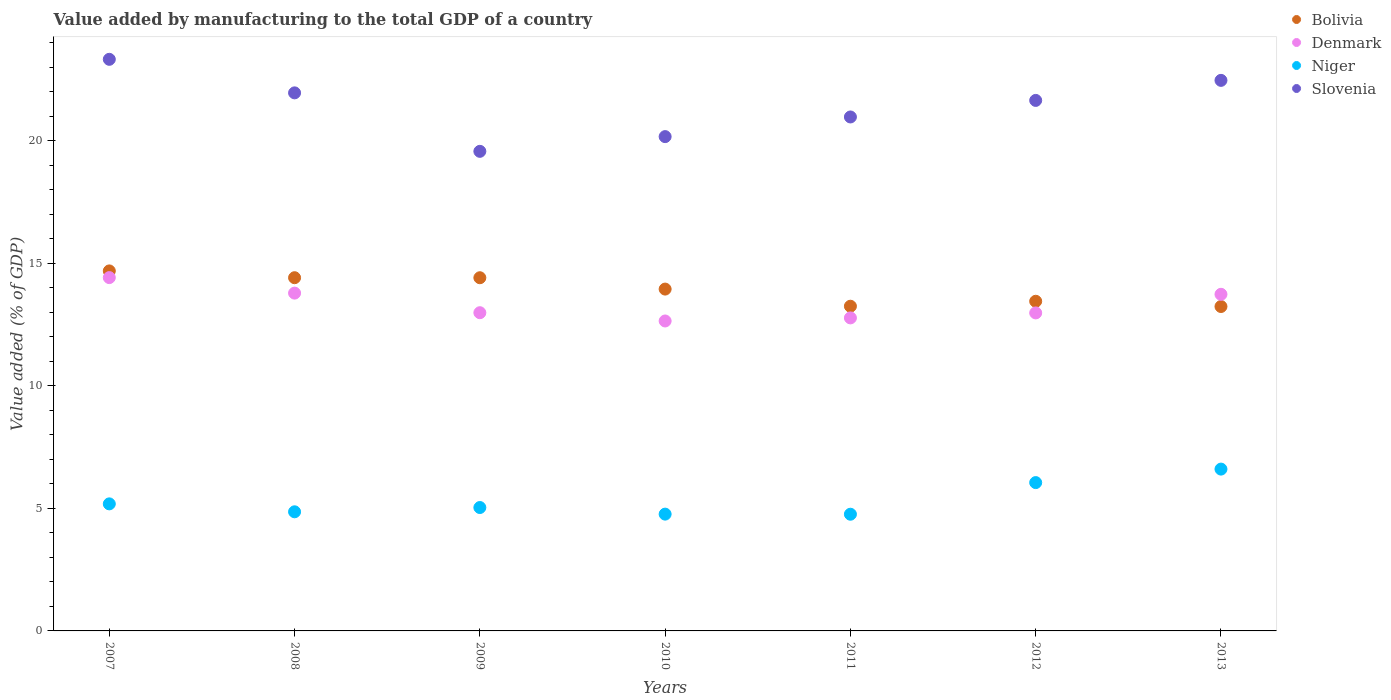How many different coloured dotlines are there?
Offer a very short reply. 4. What is the value added by manufacturing to the total GDP in Bolivia in 2010?
Make the answer very short. 13.94. Across all years, what is the maximum value added by manufacturing to the total GDP in Denmark?
Keep it short and to the point. 14.41. Across all years, what is the minimum value added by manufacturing to the total GDP in Denmark?
Ensure brevity in your answer.  12.64. In which year was the value added by manufacturing to the total GDP in Bolivia maximum?
Your response must be concise. 2007. In which year was the value added by manufacturing to the total GDP in Bolivia minimum?
Offer a terse response. 2013. What is the total value added by manufacturing to the total GDP in Niger in the graph?
Offer a terse response. 37.25. What is the difference between the value added by manufacturing to the total GDP in Bolivia in 2008 and that in 2013?
Offer a terse response. 1.17. What is the difference between the value added by manufacturing to the total GDP in Denmark in 2007 and the value added by manufacturing to the total GDP in Bolivia in 2012?
Provide a succinct answer. 0.97. What is the average value added by manufacturing to the total GDP in Niger per year?
Provide a short and direct response. 5.32. In the year 2010, what is the difference between the value added by manufacturing to the total GDP in Denmark and value added by manufacturing to the total GDP in Bolivia?
Keep it short and to the point. -1.3. What is the ratio of the value added by manufacturing to the total GDP in Bolivia in 2011 to that in 2013?
Your answer should be compact. 1. Is the value added by manufacturing to the total GDP in Niger in 2009 less than that in 2010?
Keep it short and to the point. No. What is the difference between the highest and the second highest value added by manufacturing to the total GDP in Denmark?
Provide a succinct answer. 0.63. What is the difference between the highest and the lowest value added by manufacturing to the total GDP in Denmark?
Your response must be concise. 1.77. Is the value added by manufacturing to the total GDP in Slovenia strictly less than the value added by manufacturing to the total GDP in Bolivia over the years?
Provide a succinct answer. No. How many dotlines are there?
Make the answer very short. 4. How many years are there in the graph?
Provide a succinct answer. 7. What is the difference between two consecutive major ticks on the Y-axis?
Give a very brief answer. 5. Does the graph contain grids?
Make the answer very short. No. What is the title of the graph?
Keep it short and to the point. Value added by manufacturing to the total GDP of a country. Does "Other small states" appear as one of the legend labels in the graph?
Offer a very short reply. No. What is the label or title of the X-axis?
Provide a short and direct response. Years. What is the label or title of the Y-axis?
Give a very brief answer. Value added (% of GDP). What is the Value added (% of GDP) of Bolivia in 2007?
Your response must be concise. 14.68. What is the Value added (% of GDP) of Denmark in 2007?
Ensure brevity in your answer.  14.41. What is the Value added (% of GDP) in Niger in 2007?
Provide a short and direct response. 5.18. What is the Value added (% of GDP) in Slovenia in 2007?
Provide a succinct answer. 23.31. What is the Value added (% of GDP) in Bolivia in 2008?
Give a very brief answer. 14.41. What is the Value added (% of GDP) in Denmark in 2008?
Keep it short and to the point. 13.78. What is the Value added (% of GDP) in Niger in 2008?
Your answer should be compact. 4.86. What is the Value added (% of GDP) of Slovenia in 2008?
Ensure brevity in your answer.  21.95. What is the Value added (% of GDP) of Bolivia in 2009?
Make the answer very short. 14.41. What is the Value added (% of GDP) of Denmark in 2009?
Your response must be concise. 12.98. What is the Value added (% of GDP) of Niger in 2009?
Provide a succinct answer. 5.03. What is the Value added (% of GDP) in Slovenia in 2009?
Offer a terse response. 19.56. What is the Value added (% of GDP) of Bolivia in 2010?
Your answer should be very brief. 13.94. What is the Value added (% of GDP) of Denmark in 2010?
Make the answer very short. 12.64. What is the Value added (% of GDP) in Niger in 2010?
Keep it short and to the point. 4.76. What is the Value added (% of GDP) in Slovenia in 2010?
Offer a terse response. 20.16. What is the Value added (% of GDP) in Bolivia in 2011?
Provide a short and direct response. 13.24. What is the Value added (% of GDP) of Denmark in 2011?
Provide a short and direct response. 12.77. What is the Value added (% of GDP) in Niger in 2011?
Offer a terse response. 4.76. What is the Value added (% of GDP) of Slovenia in 2011?
Give a very brief answer. 20.96. What is the Value added (% of GDP) of Bolivia in 2012?
Offer a terse response. 13.45. What is the Value added (% of GDP) of Denmark in 2012?
Keep it short and to the point. 12.97. What is the Value added (% of GDP) in Niger in 2012?
Your response must be concise. 6.05. What is the Value added (% of GDP) of Slovenia in 2012?
Keep it short and to the point. 21.64. What is the Value added (% of GDP) in Bolivia in 2013?
Give a very brief answer. 13.23. What is the Value added (% of GDP) of Denmark in 2013?
Ensure brevity in your answer.  13.73. What is the Value added (% of GDP) in Niger in 2013?
Give a very brief answer. 6.6. What is the Value added (% of GDP) in Slovenia in 2013?
Your answer should be compact. 22.45. Across all years, what is the maximum Value added (% of GDP) in Bolivia?
Ensure brevity in your answer.  14.68. Across all years, what is the maximum Value added (% of GDP) of Denmark?
Your response must be concise. 14.41. Across all years, what is the maximum Value added (% of GDP) of Niger?
Your answer should be very brief. 6.6. Across all years, what is the maximum Value added (% of GDP) of Slovenia?
Offer a terse response. 23.31. Across all years, what is the minimum Value added (% of GDP) of Bolivia?
Offer a terse response. 13.23. Across all years, what is the minimum Value added (% of GDP) of Denmark?
Offer a very short reply. 12.64. Across all years, what is the minimum Value added (% of GDP) in Niger?
Provide a succinct answer. 4.76. Across all years, what is the minimum Value added (% of GDP) in Slovenia?
Provide a short and direct response. 19.56. What is the total Value added (% of GDP) of Bolivia in the graph?
Keep it short and to the point. 97.36. What is the total Value added (% of GDP) in Denmark in the graph?
Keep it short and to the point. 93.27. What is the total Value added (% of GDP) in Niger in the graph?
Provide a short and direct response. 37.25. What is the total Value added (% of GDP) of Slovenia in the graph?
Keep it short and to the point. 150.03. What is the difference between the Value added (% of GDP) of Bolivia in 2007 and that in 2008?
Provide a succinct answer. 0.28. What is the difference between the Value added (% of GDP) of Denmark in 2007 and that in 2008?
Keep it short and to the point. 0.63. What is the difference between the Value added (% of GDP) of Niger in 2007 and that in 2008?
Give a very brief answer. 0.32. What is the difference between the Value added (% of GDP) of Slovenia in 2007 and that in 2008?
Offer a terse response. 1.37. What is the difference between the Value added (% of GDP) in Bolivia in 2007 and that in 2009?
Ensure brevity in your answer.  0.28. What is the difference between the Value added (% of GDP) in Denmark in 2007 and that in 2009?
Provide a short and direct response. 1.43. What is the difference between the Value added (% of GDP) in Niger in 2007 and that in 2009?
Provide a short and direct response. 0.15. What is the difference between the Value added (% of GDP) of Slovenia in 2007 and that in 2009?
Provide a short and direct response. 3.75. What is the difference between the Value added (% of GDP) in Bolivia in 2007 and that in 2010?
Ensure brevity in your answer.  0.74. What is the difference between the Value added (% of GDP) in Denmark in 2007 and that in 2010?
Provide a short and direct response. 1.77. What is the difference between the Value added (% of GDP) of Niger in 2007 and that in 2010?
Offer a terse response. 0.42. What is the difference between the Value added (% of GDP) of Slovenia in 2007 and that in 2010?
Provide a succinct answer. 3.15. What is the difference between the Value added (% of GDP) in Bolivia in 2007 and that in 2011?
Offer a very short reply. 1.44. What is the difference between the Value added (% of GDP) of Denmark in 2007 and that in 2011?
Give a very brief answer. 1.64. What is the difference between the Value added (% of GDP) of Niger in 2007 and that in 2011?
Make the answer very short. 0.42. What is the difference between the Value added (% of GDP) of Slovenia in 2007 and that in 2011?
Give a very brief answer. 2.35. What is the difference between the Value added (% of GDP) of Bolivia in 2007 and that in 2012?
Provide a short and direct response. 1.24. What is the difference between the Value added (% of GDP) in Denmark in 2007 and that in 2012?
Your response must be concise. 1.44. What is the difference between the Value added (% of GDP) of Niger in 2007 and that in 2012?
Your response must be concise. -0.87. What is the difference between the Value added (% of GDP) of Slovenia in 2007 and that in 2012?
Make the answer very short. 1.68. What is the difference between the Value added (% of GDP) of Bolivia in 2007 and that in 2013?
Your answer should be compact. 1.45. What is the difference between the Value added (% of GDP) of Denmark in 2007 and that in 2013?
Provide a short and direct response. 0.68. What is the difference between the Value added (% of GDP) in Niger in 2007 and that in 2013?
Provide a succinct answer. -1.42. What is the difference between the Value added (% of GDP) in Slovenia in 2007 and that in 2013?
Provide a succinct answer. 0.86. What is the difference between the Value added (% of GDP) in Bolivia in 2008 and that in 2009?
Offer a very short reply. 0. What is the difference between the Value added (% of GDP) in Denmark in 2008 and that in 2009?
Make the answer very short. 0.8. What is the difference between the Value added (% of GDP) in Niger in 2008 and that in 2009?
Your response must be concise. -0.17. What is the difference between the Value added (% of GDP) of Slovenia in 2008 and that in 2009?
Ensure brevity in your answer.  2.39. What is the difference between the Value added (% of GDP) of Bolivia in 2008 and that in 2010?
Keep it short and to the point. 0.46. What is the difference between the Value added (% of GDP) in Denmark in 2008 and that in 2010?
Give a very brief answer. 1.14. What is the difference between the Value added (% of GDP) in Niger in 2008 and that in 2010?
Provide a succinct answer. 0.09. What is the difference between the Value added (% of GDP) of Slovenia in 2008 and that in 2010?
Ensure brevity in your answer.  1.78. What is the difference between the Value added (% of GDP) in Bolivia in 2008 and that in 2011?
Your answer should be compact. 1.16. What is the difference between the Value added (% of GDP) of Denmark in 2008 and that in 2011?
Offer a terse response. 1.01. What is the difference between the Value added (% of GDP) of Niger in 2008 and that in 2011?
Offer a very short reply. 0.1. What is the difference between the Value added (% of GDP) of Slovenia in 2008 and that in 2011?
Your answer should be compact. 0.98. What is the difference between the Value added (% of GDP) in Bolivia in 2008 and that in 2012?
Provide a short and direct response. 0.96. What is the difference between the Value added (% of GDP) of Denmark in 2008 and that in 2012?
Provide a short and direct response. 0.81. What is the difference between the Value added (% of GDP) in Niger in 2008 and that in 2012?
Provide a short and direct response. -1.19. What is the difference between the Value added (% of GDP) in Slovenia in 2008 and that in 2012?
Provide a short and direct response. 0.31. What is the difference between the Value added (% of GDP) in Bolivia in 2008 and that in 2013?
Give a very brief answer. 1.17. What is the difference between the Value added (% of GDP) of Denmark in 2008 and that in 2013?
Provide a succinct answer. 0.05. What is the difference between the Value added (% of GDP) in Niger in 2008 and that in 2013?
Offer a terse response. -1.74. What is the difference between the Value added (% of GDP) of Slovenia in 2008 and that in 2013?
Ensure brevity in your answer.  -0.51. What is the difference between the Value added (% of GDP) in Bolivia in 2009 and that in 2010?
Make the answer very short. 0.46. What is the difference between the Value added (% of GDP) of Denmark in 2009 and that in 2010?
Your answer should be very brief. 0.34. What is the difference between the Value added (% of GDP) in Niger in 2009 and that in 2010?
Give a very brief answer. 0.27. What is the difference between the Value added (% of GDP) in Slovenia in 2009 and that in 2010?
Your answer should be compact. -0.6. What is the difference between the Value added (% of GDP) in Bolivia in 2009 and that in 2011?
Your response must be concise. 1.16. What is the difference between the Value added (% of GDP) in Denmark in 2009 and that in 2011?
Ensure brevity in your answer.  0.21. What is the difference between the Value added (% of GDP) of Niger in 2009 and that in 2011?
Your answer should be very brief. 0.27. What is the difference between the Value added (% of GDP) in Slovenia in 2009 and that in 2011?
Give a very brief answer. -1.4. What is the difference between the Value added (% of GDP) in Bolivia in 2009 and that in 2012?
Make the answer very short. 0.96. What is the difference between the Value added (% of GDP) of Denmark in 2009 and that in 2012?
Your answer should be very brief. 0.01. What is the difference between the Value added (% of GDP) of Niger in 2009 and that in 2012?
Ensure brevity in your answer.  -1.02. What is the difference between the Value added (% of GDP) in Slovenia in 2009 and that in 2012?
Your answer should be compact. -2.08. What is the difference between the Value added (% of GDP) in Bolivia in 2009 and that in 2013?
Provide a succinct answer. 1.17. What is the difference between the Value added (% of GDP) of Denmark in 2009 and that in 2013?
Give a very brief answer. -0.75. What is the difference between the Value added (% of GDP) of Niger in 2009 and that in 2013?
Keep it short and to the point. -1.57. What is the difference between the Value added (% of GDP) in Slovenia in 2009 and that in 2013?
Keep it short and to the point. -2.89. What is the difference between the Value added (% of GDP) in Bolivia in 2010 and that in 2011?
Your response must be concise. 0.7. What is the difference between the Value added (% of GDP) of Denmark in 2010 and that in 2011?
Your answer should be compact. -0.13. What is the difference between the Value added (% of GDP) in Niger in 2010 and that in 2011?
Your answer should be compact. 0. What is the difference between the Value added (% of GDP) in Slovenia in 2010 and that in 2011?
Provide a short and direct response. -0.8. What is the difference between the Value added (% of GDP) in Bolivia in 2010 and that in 2012?
Make the answer very short. 0.5. What is the difference between the Value added (% of GDP) in Denmark in 2010 and that in 2012?
Your answer should be very brief. -0.33. What is the difference between the Value added (% of GDP) in Niger in 2010 and that in 2012?
Ensure brevity in your answer.  -1.29. What is the difference between the Value added (% of GDP) of Slovenia in 2010 and that in 2012?
Your answer should be very brief. -1.48. What is the difference between the Value added (% of GDP) of Bolivia in 2010 and that in 2013?
Offer a terse response. 0.71. What is the difference between the Value added (% of GDP) of Denmark in 2010 and that in 2013?
Your answer should be compact. -1.09. What is the difference between the Value added (% of GDP) in Niger in 2010 and that in 2013?
Provide a short and direct response. -1.84. What is the difference between the Value added (% of GDP) of Slovenia in 2010 and that in 2013?
Keep it short and to the point. -2.29. What is the difference between the Value added (% of GDP) of Bolivia in 2011 and that in 2012?
Make the answer very short. -0.2. What is the difference between the Value added (% of GDP) of Denmark in 2011 and that in 2012?
Offer a very short reply. -0.2. What is the difference between the Value added (% of GDP) in Niger in 2011 and that in 2012?
Ensure brevity in your answer.  -1.29. What is the difference between the Value added (% of GDP) in Slovenia in 2011 and that in 2012?
Keep it short and to the point. -0.68. What is the difference between the Value added (% of GDP) in Bolivia in 2011 and that in 2013?
Provide a short and direct response. 0.01. What is the difference between the Value added (% of GDP) of Denmark in 2011 and that in 2013?
Give a very brief answer. -0.96. What is the difference between the Value added (% of GDP) of Niger in 2011 and that in 2013?
Your response must be concise. -1.84. What is the difference between the Value added (% of GDP) of Slovenia in 2011 and that in 2013?
Your answer should be compact. -1.49. What is the difference between the Value added (% of GDP) in Bolivia in 2012 and that in 2013?
Provide a succinct answer. 0.21. What is the difference between the Value added (% of GDP) of Denmark in 2012 and that in 2013?
Give a very brief answer. -0.76. What is the difference between the Value added (% of GDP) of Niger in 2012 and that in 2013?
Make the answer very short. -0.55. What is the difference between the Value added (% of GDP) in Slovenia in 2012 and that in 2013?
Offer a terse response. -0.82. What is the difference between the Value added (% of GDP) in Bolivia in 2007 and the Value added (% of GDP) in Denmark in 2008?
Give a very brief answer. 0.91. What is the difference between the Value added (% of GDP) in Bolivia in 2007 and the Value added (% of GDP) in Niger in 2008?
Offer a terse response. 9.82. What is the difference between the Value added (% of GDP) of Bolivia in 2007 and the Value added (% of GDP) of Slovenia in 2008?
Your answer should be very brief. -7.26. What is the difference between the Value added (% of GDP) of Denmark in 2007 and the Value added (% of GDP) of Niger in 2008?
Offer a terse response. 9.55. What is the difference between the Value added (% of GDP) of Denmark in 2007 and the Value added (% of GDP) of Slovenia in 2008?
Provide a succinct answer. -7.53. What is the difference between the Value added (% of GDP) in Niger in 2007 and the Value added (% of GDP) in Slovenia in 2008?
Provide a short and direct response. -16.76. What is the difference between the Value added (% of GDP) of Bolivia in 2007 and the Value added (% of GDP) of Denmark in 2009?
Your response must be concise. 1.7. What is the difference between the Value added (% of GDP) of Bolivia in 2007 and the Value added (% of GDP) of Niger in 2009?
Offer a very short reply. 9.65. What is the difference between the Value added (% of GDP) in Bolivia in 2007 and the Value added (% of GDP) in Slovenia in 2009?
Provide a succinct answer. -4.88. What is the difference between the Value added (% of GDP) of Denmark in 2007 and the Value added (% of GDP) of Niger in 2009?
Offer a very short reply. 9.38. What is the difference between the Value added (% of GDP) in Denmark in 2007 and the Value added (% of GDP) in Slovenia in 2009?
Provide a succinct answer. -5.15. What is the difference between the Value added (% of GDP) in Niger in 2007 and the Value added (% of GDP) in Slovenia in 2009?
Your answer should be very brief. -14.38. What is the difference between the Value added (% of GDP) of Bolivia in 2007 and the Value added (% of GDP) of Denmark in 2010?
Offer a terse response. 2.04. What is the difference between the Value added (% of GDP) in Bolivia in 2007 and the Value added (% of GDP) in Niger in 2010?
Your answer should be compact. 9.92. What is the difference between the Value added (% of GDP) of Bolivia in 2007 and the Value added (% of GDP) of Slovenia in 2010?
Provide a succinct answer. -5.48. What is the difference between the Value added (% of GDP) in Denmark in 2007 and the Value added (% of GDP) in Niger in 2010?
Your answer should be compact. 9.65. What is the difference between the Value added (% of GDP) of Denmark in 2007 and the Value added (% of GDP) of Slovenia in 2010?
Make the answer very short. -5.75. What is the difference between the Value added (% of GDP) in Niger in 2007 and the Value added (% of GDP) in Slovenia in 2010?
Your answer should be compact. -14.98. What is the difference between the Value added (% of GDP) in Bolivia in 2007 and the Value added (% of GDP) in Denmark in 2011?
Ensure brevity in your answer.  1.92. What is the difference between the Value added (% of GDP) of Bolivia in 2007 and the Value added (% of GDP) of Niger in 2011?
Provide a short and direct response. 9.92. What is the difference between the Value added (% of GDP) in Bolivia in 2007 and the Value added (% of GDP) in Slovenia in 2011?
Your response must be concise. -6.28. What is the difference between the Value added (% of GDP) in Denmark in 2007 and the Value added (% of GDP) in Niger in 2011?
Keep it short and to the point. 9.65. What is the difference between the Value added (% of GDP) in Denmark in 2007 and the Value added (% of GDP) in Slovenia in 2011?
Give a very brief answer. -6.55. What is the difference between the Value added (% of GDP) in Niger in 2007 and the Value added (% of GDP) in Slovenia in 2011?
Give a very brief answer. -15.78. What is the difference between the Value added (% of GDP) in Bolivia in 2007 and the Value added (% of GDP) in Denmark in 2012?
Provide a short and direct response. 1.71. What is the difference between the Value added (% of GDP) of Bolivia in 2007 and the Value added (% of GDP) of Niger in 2012?
Your answer should be very brief. 8.63. What is the difference between the Value added (% of GDP) of Bolivia in 2007 and the Value added (% of GDP) of Slovenia in 2012?
Ensure brevity in your answer.  -6.95. What is the difference between the Value added (% of GDP) in Denmark in 2007 and the Value added (% of GDP) in Niger in 2012?
Make the answer very short. 8.36. What is the difference between the Value added (% of GDP) in Denmark in 2007 and the Value added (% of GDP) in Slovenia in 2012?
Keep it short and to the point. -7.23. What is the difference between the Value added (% of GDP) of Niger in 2007 and the Value added (% of GDP) of Slovenia in 2012?
Ensure brevity in your answer.  -16.46. What is the difference between the Value added (% of GDP) in Bolivia in 2007 and the Value added (% of GDP) in Denmark in 2013?
Your response must be concise. 0.95. What is the difference between the Value added (% of GDP) of Bolivia in 2007 and the Value added (% of GDP) of Niger in 2013?
Your response must be concise. 8.08. What is the difference between the Value added (% of GDP) in Bolivia in 2007 and the Value added (% of GDP) in Slovenia in 2013?
Your answer should be compact. -7.77. What is the difference between the Value added (% of GDP) in Denmark in 2007 and the Value added (% of GDP) in Niger in 2013?
Your answer should be very brief. 7.81. What is the difference between the Value added (% of GDP) in Denmark in 2007 and the Value added (% of GDP) in Slovenia in 2013?
Your response must be concise. -8.04. What is the difference between the Value added (% of GDP) in Niger in 2007 and the Value added (% of GDP) in Slovenia in 2013?
Your response must be concise. -17.27. What is the difference between the Value added (% of GDP) of Bolivia in 2008 and the Value added (% of GDP) of Denmark in 2009?
Offer a terse response. 1.43. What is the difference between the Value added (% of GDP) of Bolivia in 2008 and the Value added (% of GDP) of Niger in 2009?
Offer a terse response. 9.37. What is the difference between the Value added (% of GDP) of Bolivia in 2008 and the Value added (% of GDP) of Slovenia in 2009?
Your response must be concise. -5.15. What is the difference between the Value added (% of GDP) in Denmark in 2008 and the Value added (% of GDP) in Niger in 2009?
Your answer should be compact. 8.75. What is the difference between the Value added (% of GDP) in Denmark in 2008 and the Value added (% of GDP) in Slovenia in 2009?
Offer a very short reply. -5.78. What is the difference between the Value added (% of GDP) in Niger in 2008 and the Value added (% of GDP) in Slovenia in 2009?
Give a very brief answer. -14.7. What is the difference between the Value added (% of GDP) in Bolivia in 2008 and the Value added (% of GDP) in Denmark in 2010?
Provide a succinct answer. 1.76. What is the difference between the Value added (% of GDP) in Bolivia in 2008 and the Value added (% of GDP) in Niger in 2010?
Keep it short and to the point. 9.64. What is the difference between the Value added (% of GDP) of Bolivia in 2008 and the Value added (% of GDP) of Slovenia in 2010?
Give a very brief answer. -5.75. What is the difference between the Value added (% of GDP) of Denmark in 2008 and the Value added (% of GDP) of Niger in 2010?
Your answer should be compact. 9.01. What is the difference between the Value added (% of GDP) of Denmark in 2008 and the Value added (% of GDP) of Slovenia in 2010?
Your answer should be compact. -6.38. What is the difference between the Value added (% of GDP) in Niger in 2008 and the Value added (% of GDP) in Slovenia in 2010?
Offer a terse response. -15.3. What is the difference between the Value added (% of GDP) of Bolivia in 2008 and the Value added (% of GDP) of Denmark in 2011?
Offer a terse response. 1.64. What is the difference between the Value added (% of GDP) of Bolivia in 2008 and the Value added (% of GDP) of Niger in 2011?
Offer a terse response. 9.65. What is the difference between the Value added (% of GDP) of Bolivia in 2008 and the Value added (% of GDP) of Slovenia in 2011?
Keep it short and to the point. -6.56. What is the difference between the Value added (% of GDP) of Denmark in 2008 and the Value added (% of GDP) of Niger in 2011?
Provide a succinct answer. 9.02. What is the difference between the Value added (% of GDP) of Denmark in 2008 and the Value added (% of GDP) of Slovenia in 2011?
Offer a terse response. -7.18. What is the difference between the Value added (% of GDP) of Niger in 2008 and the Value added (% of GDP) of Slovenia in 2011?
Your response must be concise. -16.1. What is the difference between the Value added (% of GDP) in Bolivia in 2008 and the Value added (% of GDP) in Denmark in 2012?
Offer a terse response. 1.44. What is the difference between the Value added (% of GDP) in Bolivia in 2008 and the Value added (% of GDP) in Niger in 2012?
Your answer should be compact. 8.36. What is the difference between the Value added (% of GDP) in Bolivia in 2008 and the Value added (% of GDP) in Slovenia in 2012?
Your answer should be very brief. -7.23. What is the difference between the Value added (% of GDP) in Denmark in 2008 and the Value added (% of GDP) in Niger in 2012?
Provide a short and direct response. 7.73. What is the difference between the Value added (% of GDP) of Denmark in 2008 and the Value added (% of GDP) of Slovenia in 2012?
Your answer should be very brief. -7.86. What is the difference between the Value added (% of GDP) of Niger in 2008 and the Value added (% of GDP) of Slovenia in 2012?
Give a very brief answer. -16.78. What is the difference between the Value added (% of GDP) of Bolivia in 2008 and the Value added (% of GDP) of Denmark in 2013?
Give a very brief answer. 0.68. What is the difference between the Value added (% of GDP) in Bolivia in 2008 and the Value added (% of GDP) in Niger in 2013?
Provide a succinct answer. 7.81. What is the difference between the Value added (% of GDP) in Bolivia in 2008 and the Value added (% of GDP) in Slovenia in 2013?
Provide a succinct answer. -8.05. What is the difference between the Value added (% of GDP) in Denmark in 2008 and the Value added (% of GDP) in Niger in 2013?
Provide a succinct answer. 7.18. What is the difference between the Value added (% of GDP) in Denmark in 2008 and the Value added (% of GDP) in Slovenia in 2013?
Provide a short and direct response. -8.68. What is the difference between the Value added (% of GDP) in Niger in 2008 and the Value added (% of GDP) in Slovenia in 2013?
Offer a terse response. -17.6. What is the difference between the Value added (% of GDP) of Bolivia in 2009 and the Value added (% of GDP) of Denmark in 2010?
Offer a terse response. 1.76. What is the difference between the Value added (% of GDP) in Bolivia in 2009 and the Value added (% of GDP) in Niger in 2010?
Your answer should be compact. 9.64. What is the difference between the Value added (% of GDP) of Bolivia in 2009 and the Value added (% of GDP) of Slovenia in 2010?
Give a very brief answer. -5.76. What is the difference between the Value added (% of GDP) of Denmark in 2009 and the Value added (% of GDP) of Niger in 2010?
Your answer should be compact. 8.22. What is the difference between the Value added (% of GDP) of Denmark in 2009 and the Value added (% of GDP) of Slovenia in 2010?
Keep it short and to the point. -7.18. What is the difference between the Value added (% of GDP) of Niger in 2009 and the Value added (% of GDP) of Slovenia in 2010?
Your response must be concise. -15.13. What is the difference between the Value added (% of GDP) of Bolivia in 2009 and the Value added (% of GDP) of Denmark in 2011?
Offer a terse response. 1.64. What is the difference between the Value added (% of GDP) of Bolivia in 2009 and the Value added (% of GDP) of Niger in 2011?
Your response must be concise. 9.65. What is the difference between the Value added (% of GDP) of Bolivia in 2009 and the Value added (% of GDP) of Slovenia in 2011?
Your answer should be very brief. -6.56. What is the difference between the Value added (% of GDP) in Denmark in 2009 and the Value added (% of GDP) in Niger in 2011?
Provide a succinct answer. 8.22. What is the difference between the Value added (% of GDP) in Denmark in 2009 and the Value added (% of GDP) in Slovenia in 2011?
Your answer should be compact. -7.98. What is the difference between the Value added (% of GDP) of Niger in 2009 and the Value added (% of GDP) of Slovenia in 2011?
Your answer should be compact. -15.93. What is the difference between the Value added (% of GDP) in Bolivia in 2009 and the Value added (% of GDP) in Denmark in 2012?
Make the answer very short. 1.44. What is the difference between the Value added (% of GDP) of Bolivia in 2009 and the Value added (% of GDP) of Niger in 2012?
Offer a very short reply. 8.36. What is the difference between the Value added (% of GDP) of Bolivia in 2009 and the Value added (% of GDP) of Slovenia in 2012?
Your response must be concise. -7.23. What is the difference between the Value added (% of GDP) in Denmark in 2009 and the Value added (% of GDP) in Niger in 2012?
Ensure brevity in your answer.  6.93. What is the difference between the Value added (% of GDP) in Denmark in 2009 and the Value added (% of GDP) in Slovenia in 2012?
Provide a succinct answer. -8.66. What is the difference between the Value added (% of GDP) of Niger in 2009 and the Value added (% of GDP) of Slovenia in 2012?
Offer a terse response. -16.6. What is the difference between the Value added (% of GDP) in Bolivia in 2009 and the Value added (% of GDP) in Denmark in 2013?
Your response must be concise. 0.68. What is the difference between the Value added (% of GDP) of Bolivia in 2009 and the Value added (% of GDP) of Niger in 2013?
Your response must be concise. 7.81. What is the difference between the Value added (% of GDP) of Bolivia in 2009 and the Value added (% of GDP) of Slovenia in 2013?
Ensure brevity in your answer.  -8.05. What is the difference between the Value added (% of GDP) of Denmark in 2009 and the Value added (% of GDP) of Niger in 2013?
Your response must be concise. 6.38. What is the difference between the Value added (% of GDP) of Denmark in 2009 and the Value added (% of GDP) of Slovenia in 2013?
Offer a very short reply. -9.48. What is the difference between the Value added (% of GDP) of Niger in 2009 and the Value added (% of GDP) of Slovenia in 2013?
Your answer should be compact. -17.42. What is the difference between the Value added (% of GDP) of Bolivia in 2010 and the Value added (% of GDP) of Denmark in 2011?
Provide a short and direct response. 1.18. What is the difference between the Value added (% of GDP) of Bolivia in 2010 and the Value added (% of GDP) of Niger in 2011?
Ensure brevity in your answer.  9.18. What is the difference between the Value added (% of GDP) in Bolivia in 2010 and the Value added (% of GDP) in Slovenia in 2011?
Provide a short and direct response. -7.02. What is the difference between the Value added (% of GDP) of Denmark in 2010 and the Value added (% of GDP) of Niger in 2011?
Your response must be concise. 7.88. What is the difference between the Value added (% of GDP) of Denmark in 2010 and the Value added (% of GDP) of Slovenia in 2011?
Offer a terse response. -8.32. What is the difference between the Value added (% of GDP) of Niger in 2010 and the Value added (% of GDP) of Slovenia in 2011?
Ensure brevity in your answer.  -16.2. What is the difference between the Value added (% of GDP) of Bolivia in 2010 and the Value added (% of GDP) of Denmark in 2012?
Ensure brevity in your answer.  0.97. What is the difference between the Value added (% of GDP) in Bolivia in 2010 and the Value added (% of GDP) in Niger in 2012?
Keep it short and to the point. 7.89. What is the difference between the Value added (% of GDP) of Bolivia in 2010 and the Value added (% of GDP) of Slovenia in 2012?
Keep it short and to the point. -7.7. What is the difference between the Value added (% of GDP) of Denmark in 2010 and the Value added (% of GDP) of Niger in 2012?
Offer a terse response. 6.59. What is the difference between the Value added (% of GDP) in Denmark in 2010 and the Value added (% of GDP) in Slovenia in 2012?
Your answer should be compact. -9. What is the difference between the Value added (% of GDP) in Niger in 2010 and the Value added (% of GDP) in Slovenia in 2012?
Provide a short and direct response. -16.87. What is the difference between the Value added (% of GDP) in Bolivia in 2010 and the Value added (% of GDP) in Denmark in 2013?
Make the answer very short. 0.21. What is the difference between the Value added (% of GDP) in Bolivia in 2010 and the Value added (% of GDP) in Niger in 2013?
Make the answer very short. 7.34. What is the difference between the Value added (% of GDP) in Bolivia in 2010 and the Value added (% of GDP) in Slovenia in 2013?
Your answer should be very brief. -8.51. What is the difference between the Value added (% of GDP) in Denmark in 2010 and the Value added (% of GDP) in Niger in 2013?
Give a very brief answer. 6.04. What is the difference between the Value added (% of GDP) in Denmark in 2010 and the Value added (% of GDP) in Slovenia in 2013?
Provide a succinct answer. -9.81. What is the difference between the Value added (% of GDP) in Niger in 2010 and the Value added (% of GDP) in Slovenia in 2013?
Your response must be concise. -17.69. What is the difference between the Value added (% of GDP) in Bolivia in 2011 and the Value added (% of GDP) in Denmark in 2012?
Keep it short and to the point. 0.27. What is the difference between the Value added (% of GDP) of Bolivia in 2011 and the Value added (% of GDP) of Niger in 2012?
Offer a terse response. 7.19. What is the difference between the Value added (% of GDP) of Bolivia in 2011 and the Value added (% of GDP) of Slovenia in 2012?
Your answer should be compact. -8.39. What is the difference between the Value added (% of GDP) of Denmark in 2011 and the Value added (% of GDP) of Niger in 2012?
Provide a succinct answer. 6.72. What is the difference between the Value added (% of GDP) of Denmark in 2011 and the Value added (% of GDP) of Slovenia in 2012?
Provide a succinct answer. -8.87. What is the difference between the Value added (% of GDP) of Niger in 2011 and the Value added (% of GDP) of Slovenia in 2012?
Provide a short and direct response. -16.88. What is the difference between the Value added (% of GDP) in Bolivia in 2011 and the Value added (% of GDP) in Denmark in 2013?
Give a very brief answer. -0.49. What is the difference between the Value added (% of GDP) in Bolivia in 2011 and the Value added (% of GDP) in Niger in 2013?
Ensure brevity in your answer.  6.64. What is the difference between the Value added (% of GDP) of Bolivia in 2011 and the Value added (% of GDP) of Slovenia in 2013?
Your response must be concise. -9.21. What is the difference between the Value added (% of GDP) in Denmark in 2011 and the Value added (% of GDP) in Niger in 2013?
Your answer should be compact. 6.17. What is the difference between the Value added (% of GDP) in Denmark in 2011 and the Value added (% of GDP) in Slovenia in 2013?
Offer a very short reply. -9.69. What is the difference between the Value added (% of GDP) of Niger in 2011 and the Value added (% of GDP) of Slovenia in 2013?
Ensure brevity in your answer.  -17.7. What is the difference between the Value added (% of GDP) of Bolivia in 2012 and the Value added (% of GDP) of Denmark in 2013?
Offer a terse response. -0.28. What is the difference between the Value added (% of GDP) of Bolivia in 2012 and the Value added (% of GDP) of Niger in 2013?
Provide a succinct answer. 6.85. What is the difference between the Value added (% of GDP) of Bolivia in 2012 and the Value added (% of GDP) of Slovenia in 2013?
Provide a short and direct response. -9.01. What is the difference between the Value added (% of GDP) of Denmark in 2012 and the Value added (% of GDP) of Niger in 2013?
Give a very brief answer. 6.37. What is the difference between the Value added (% of GDP) in Denmark in 2012 and the Value added (% of GDP) in Slovenia in 2013?
Give a very brief answer. -9.48. What is the difference between the Value added (% of GDP) of Niger in 2012 and the Value added (% of GDP) of Slovenia in 2013?
Make the answer very short. -16.41. What is the average Value added (% of GDP) of Bolivia per year?
Make the answer very short. 13.91. What is the average Value added (% of GDP) of Denmark per year?
Give a very brief answer. 13.32. What is the average Value added (% of GDP) of Niger per year?
Ensure brevity in your answer.  5.32. What is the average Value added (% of GDP) of Slovenia per year?
Offer a very short reply. 21.43. In the year 2007, what is the difference between the Value added (% of GDP) in Bolivia and Value added (% of GDP) in Denmark?
Your answer should be compact. 0.27. In the year 2007, what is the difference between the Value added (% of GDP) in Bolivia and Value added (% of GDP) in Niger?
Give a very brief answer. 9.5. In the year 2007, what is the difference between the Value added (% of GDP) of Bolivia and Value added (% of GDP) of Slovenia?
Give a very brief answer. -8.63. In the year 2007, what is the difference between the Value added (% of GDP) of Denmark and Value added (% of GDP) of Niger?
Provide a short and direct response. 9.23. In the year 2007, what is the difference between the Value added (% of GDP) in Denmark and Value added (% of GDP) in Slovenia?
Provide a short and direct response. -8.9. In the year 2007, what is the difference between the Value added (% of GDP) in Niger and Value added (% of GDP) in Slovenia?
Provide a succinct answer. -18.13. In the year 2008, what is the difference between the Value added (% of GDP) of Bolivia and Value added (% of GDP) of Denmark?
Keep it short and to the point. 0.63. In the year 2008, what is the difference between the Value added (% of GDP) of Bolivia and Value added (% of GDP) of Niger?
Your answer should be very brief. 9.55. In the year 2008, what is the difference between the Value added (% of GDP) of Bolivia and Value added (% of GDP) of Slovenia?
Your answer should be compact. -7.54. In the year 2008, what is the difference between the Value added (% of GDP) of Denmark and Value added (% of GDP) of Niger?
Your answer should be very brief. 8.92. In the year 2008, what is the difference between the Value added (% of GDP) of Denmark and Value added (% of GDP) of Slovenia?
Your answer should be very brief. -8.17. In the year 2008, what is the difference between the Value added (% of GDP) of Niger and Value added (% of GDP) of Slovenia?
Make the answer very short. -17.09. In the year 2009, what is the difference between the Value added (% of GDP) of Bolivia and Value added (% of GDP) of Denmark?
Keep it short and to the point. 1.43. In the year 2009, what is the difference between the Value added (% of GDP) in Bolivia and Value added (% of GDP) in Niger?
Your response must be concise. 9.37. In the year 2009, what is the difference between the Value added (% of GDP) in Bolivia and Value added (% of GDP) in Slovenia?
Ensure brevity in your answer.  -5.15. In the year 2009, what is the difference between the Value added (% of GDP) of Denmark and Value added (% of GDP) of Niger?
Offer a terse response. 7.95. In the year 2009, what is the difference between the Value added (% of GDP) of Denmark and Value added (% of GDP) of Slovenia?
Ensure brevity in your answer.  -6.58. In the year 2009, what is the difference between the Value added (% of GDP) of Niger and Value added (% of GDP) of Slovenia?
Your answer should be very brief. -14.53. In the year 2010, what is the difference between the Value added (% of GDP) in Bolivia and Value added (% of GDP) in Denmark?
Make the answer very short. 1.3. In the year 2010, what is the difference between the Value added (% of GDP) of Bolivia and Value added (% of GDP) of Niger?
Ensure brevity in your answer.  9.18. In the year 2010, what is the difference between the Value added (% of GDP) of Bolivia and Value added (% of GDP) of Slovenia?
Give a very brief answer. -6.22. In the year 2010, what is the difference between the Value added (% of GDP) of Denmark and Value added (% of GDP) of Niger?
Your answer should be very brief. 7.88. In the year 2010, what is the difference between the Value added (% of GDP) of Denmark and Value added (% of GDP) of Slovenia?
Your answer should be very brief. -7.52. In the year 2010, what is the difference between the Value added (% of GDP) in Niger and Value added (% of GDP) in Slovenia?
Your response must be concise. -15.4. In the year 2011, what is the difference between the Value added (% of GDP) in Bolivia and Value added (% of GDP) in Denmark?
Make the answer very short. 0.48. In the year 2011, what is the difference between the Value added (% of GDP) in Bolivia and Value added (% of GDP) in Niger?
Keep it short and to the point. 8.48. In the year 2011, what is the difference between the Value added (% of GDP) in Bolivia and Value added (% of GDP) in Slovenia?
Your answer should be very brief. -7.72. In the year 2011, what is the difference between the Value added (% of GDP) of Denmark and Value added (% of GDP) of Niger?
Provide a short and direct response. 8.01. In the year 2011, what is the difference between the Value added (% of GDP) of Denmark and Value added (% of GDP) of Slovenia?
Ensure brevity in your answer.  -8.2. In the year 2011, what is the difference between the Value added (% of GDP) of Niger and Value added (% of GDP) of Slovenia?
Offer a terse response. -16.2. In the year 2012, what is the difference between the Value added (% of GDP) of Bolivia and Value added (% of GDP) of Denmark?
Ensure brevity in your answer.  0.48. In the year 2012, what is the difference between the Value added (% of GDP) of Bolivia and Value added (% of GDP) of Niger?
Your response must be concise. 7.4. In the year 2012, what is the difference between the Value added (% of GDP) of Bolivia and Value added (% of GDP) of Slovenia?
Provide a succinct answer. -8.19. In the year 2012, what is the difference between the Value added (% of GDP) in Denmark and Value added (% of GDP) in Niger?
Keep it short and to the point. 6.92. In the year 2012, what is the difference between the Value added (% of GDP) in Denmark and Value added (% of GDP) in Slovenia?
Provide a short and direct response. -8.67. In the year 2012, what is the difference between the Value added (% of GDP) in Niger and Value added (% of GDP) in Slovenia?
Provide a short and direct response. -15.59. In the year 2013, what is the difference between the Value added (% of GDP) of Bolivia and Value added (% of GDP) of Denmark?
Your answer should be very brief. -0.5. In the year 2013, what is the difference between the Value added (% of GDP) in Bolivia and Value added (% of GDP) in Niger?
Keep it short and to the point. 6.63. In the year 2013, what is the difference between the Value added (% of GDP) in Bolivia and Value added (% of GDP) in Slovenia?
Make the answer very short. -9.22. In the year 2013, what is the difference between the Value added (% of GDP) in Denmark and Value added (% of GDP) in Niger?
Keep it short and to the point. 7.13. In the year 2013, what is the difference between the Value added (% of GDP) in Denmark and Value added (% of GDP) in Slovenia?
Offer a terse response. -8.73. In the year 2013, what is the difference between the Value added (% of GDP) of Niger and Value added (% of GDP) of Slovenia?
Offer a very short reply. -15.86. What is the ratio of the Value added (% of GDP) of Bolivia in 2007 to that in 2008?
Offer a very short reply. 1.02. What is the ratio of the Value added (% of GDP) in Denmark in 2007 to that in 2008?
Keep it short and to the point. 1.05. What is the ratio of the Value added (% of GDP) in Niger in 2007 to that in 2008?
Offer a very short reply. 1.07. What is the ratio of the Value added (% of GDP) in Slovenia in 2007 to that in 2008?
Offer a very short reply. 1.06. What is the ratio of the Value added (% of GDP) in Bolivia in 2007 to that in 2009?
Give a very brief answer. 1.02. What is the ratio of the Value added (% of GDP) of Denmark in 2007 to that in 2009?
Ensure brevity in your answer.  1.11. What is the ratio of the Value added (% of GDP) in Niger in 2007 to that in 2009?
Your answer should be very brief. 1.03. What is the ratio of the Value added (% of GDP) in Slovenia in 2007 to that in 2009?
Ensure brevity in your answer.  1.19. What is the ratio of the Value added (% of GDP) of Bolivia in 2007 to that in 2010?
Your response must be concise. 1.05. What is the ratio of the Value added (% of GDP) of Denmark in 2007 to that in 2010?
Your answer should be very brief. 1.14. What is the ratio of the Value added (% of GDP) in Niger in 2007 to that in 2010?
Give a very brief answer. 1.09. What is the ratio of the Value added (% of GDP) of Slovenia in 2007 to that in 2010?
Make the answer very short. 1.16. What is the ratio of the Value added (% of GDP) in Bolivia in 2007 to that in 2011?
Keep it short and to the point. 1.11. What is the ratio of the Value added (% of GDP) in Denmark in 2007 to that in 2011?
Your answer should be very brief. 1.13. What is the ratio of the Value added (% of GDP) in Niger in 2007 to that in 2011?
Provide a succinct answer. 1.09. What is the ratio of the Value added (% of GDP) in Slovenia in 2007 to that in 2011?
Keep it short and to the point. 1.11. What is the ratio of the Value added (% of GDP) in Bolivia in 2007 to that in 2012?
Make the answer very short. 1.09. What is the ratio of the Value added (% of GDP) in Niger in 2007 to that in 2012?
Your response must be concise. 0.86. What is the ratio of the Value added (% of GDP) of Slovenia in 2007 to that in 2012?
Your response must be concise. 1.08. What is the ratio of the Value added (% of GDP) in Bolivia in 2007 to that in 2013?
Your answer should be compact. 1.11. What is the ratio of the Value added (% of GDP) of Denmark in 2007 to that in 2013?
Make the answer very short. 1.05. What is the ratio of the Value added (% of GDP) of Niger in 2007 to that in 2013?
Give a very brief answer. 0.79. What is the ratio of the Value added (% of GDP) in Slovenia in 2007 to that in 2013?
Provide a short and direct response. 1.04. What is the ratio of the Value added (% of GDP) of Bolivia in 2008 to that in 2009?
Offer a terse response. 1. What is the ratio of the Value added (% of GDP) of Denmark in 2008 to that in 2009?
Give a very brief answer. 1.06. What is the ratio of the Value added (% of GDP) in Niger in 2008 to that in 2009?
Your answer should be very brief. 0.97. What is the ratio of the Value added (% of GDP) in Slovenia in 2008 to that in 2009?
Provide a succinct answer. 1.12. What is the ratio of the Value added (% of GDP) of Denmark in 2008 to that in 2010?
Provide a short and direct response. 1.09. What is the ratio of the Value added (% of GDP) of Niger in 2008 to that in 2010?
Keep it short and to the point. 1.02. What is the ratio of the Value added (% of GDP) of Slovenia in 2008 to that in 2010?
Keep it short and to the point. 1.09. What is the ratio of the Value added (% of GDP) of Bolivia in 2008 to that in 2011?
Give a very brief answer. 1.09. What is the ratio of the Value added (% of GDP) of Denmark in 2008 to that in 2011?
Provide a succinct answer. 1.08. What is the ratio of the Value added (% of GDP) in Niger in 2008 to that in 2011?
Offer a terse response. 1.02. What is the ratio of the Value added (% of GDP) in Slovenia in 2008 to that in 2011?
Make the answer very short. 1.05. What is the ratio of the Value added (% of GDP) of Bolivia in 2008 to that in 2012?
Offer a terse response. 1.07. What is the ratio of the Value added (% of GDP) in Denmark in 2008 to that in 2012?
Keep it short and to the point. 1.06. What is the ratio of the Value added (% of GDP) in Niger in 2008 to that in 2012?
Offer a terse response. 0.8. What is the ratio of the Value added (% of GDP) of Slovenia in 2008 to that in 2012?
Keep it short and to the point. 1.01. What is the ratio of the Value added (% of GDP) in Bolivia in 2008 to that in 2013?
Give a very brief answer. 1.09. What is the ratio of the Value added (% of GDP) of Denmark in 2008 to that in 2013?
Offer a terse response. 1. What is the ratio of the Value added (% of GDP) in Niger in 2008 to that in 2013?
Provide a short and direct response. 0.74. What is the ratio of the Value added (% of GDP) in Slovenia in 2008 to that in 2013?
Your answer should be compact. 0.98. What is the ratio of the Value added (% of GDP) of Bolivia in 2009 to that in 2010?
Keep it short and to the point. 1.03. What is the ratio of the Value added (% of GDP) of Denmark in 2009 to that in 2010?
Provide a succinct answer. 1.03. What is the ratio of the Value added (% of GDP) in Niger in 2009 to that in 2010?
Provide a short and direct response. 1.06. What is the ratio of the Value added (% of GDP) of Slovenia in 2009 to that in 2010?
Ensure brevity in your answer.  0.97. What is the ratio of the Value added (% of GDP) in Bolivia in 2009 to that in 2011?
Make the answer very short. 1.09. What is the ratio of the Value added (% of GDP) of Denmark in 2009 to that in 2011?
Ensure brevity in your answer.  1.02. What is the ratio of the Value added (% of GDP) in Niger in 2009 to that in 2011?
Give a very brief answer. 1.06. What is the ratio of the Value added (% of GDP) of Slovenia in 2009 to that in 2011?
Keep it short and to the point. 0.93. What is the ratio of the Value added (% of GDP) of Bolivia in 2009 to that in 2012?
Provide a succinct answer. 1.07. What is the ratio of the Value added (% of GDP) of Niger in 2009 to that in 2012?
Offer a terse response. 0.83. What is the ratio of the Value added (% of GDP) of Slovenia in 2009 to that in 2012?
Make the answer very short. 0.9. What is the ratio of the Value added (% of GDP) in Bolivia in 2009 to that in 2013?
Provide a short and direct response. 1.09. What is the ratio of the Value added (% of GDP) in Denmark in 2009 to that in 2013?
Make the answer very short. 0.95. What is the ratio of the Value added (% of GDP) in Niger in 2009 to that in 2013?
Provide a short and direct response. 0.76. What is the ratio of the Value added (% of GDP) of Slovenia in 2009 to that in 2013?
Give a very brief answer. 0.87. What is the ratio of the Value added (% of GDP) in Bolivia in 2010 to that in 2011?
Your answer should be very brief. 1.05. What is the ratio of the Value added (% of GDP) of Denmark in 2010 to that in 2011?
Provide a succinct answer. 0.99. What is the ratio of the Value added (% of GDP) of Niger in 2010 to that in 2011?
Ensure brevity in your answer.  1. What is the ratio of the Value added (% of GDP) of Slovenia in 2010 to that in 2011?
Make the answer very short. 0.96. What is the ratio of the Value added (% of GDP) of Bolivia in 2010 to that in 2012?
Ensure brevity in your answer.  1.04. What is the ratio of the Value added (% of GDP) in Denmark in 2010 to that in 2012?
Provide a succinct answer. 0.97. What is the ratio of the Value added (% of GDP) in Niger in 2010 to that in 2012?
Keep it short and to the point. 0.79. What is the ratio of the Value added (% of GDP) in Slovenia in 2010 to that in 2012?
Offer a terse response. 0.93. What is the ratio of the Value added (% of GDP) of Bolivia in 2010 to that in 2013?
Your answer should be very brief. 1.05. What is the ratio of the Value added (% of GDP) of Denmark in 2010 to that in 2013?
Your answer should be compact. 0.92. What is the ratio of the Value added (% of GDP) in Niger in 2010 to that in 2013?
Keep it short and to the point. 0.72. What is the ratio of the Value added (% of GDP) of Slovenia in 2010 to that in 2013?
Offer a terse response. 0.9. What is the ratio of the Value added (% of GDP) of Bolivia in 2011 to that in 2012?
Provide a succinct answer. 0.98. What is the ratio of the Value added (% of GDP) in Denmark in 2011 to that in 2012?
Offer a very short reply. 0.98. What is the ratio of the Value added (% of GDP) of Niger in 2011 to that in 2012?
Your response must be concise. 0.79. What is the ratio of the Value added (% of GDP) in Slovenia in 2011 to that in 2012?
Your answer should be very brief. 0.97. What is the ratio of the Value added (% of GDP) in Denmark in 2011 to that in 2013?
Make the answer very short. 0.93. What is the ratio of the Value added (% of GDP) in Niger in 2011 to that in 2013?
Ensure brevity in your answer.  0.72. What is the ratio of the Value added (% of GDP) of Slovenia in 2011 to that in 2013?
Keep it short and to the point. 0.93. What is the ratio of the Value added (% of GDP) of Bolivia in 2012 to that in 2013?
Make the answer very short. 1.02. What is the ratio of the Value added (% of GDP) of Denmark in 2012 to that in 2013?
Provide a succinct answer. 0.94. What is the ratio of the Value added (% of GDP) of Niger in 2012 to that in 2013?
Keep it short and to the point. 0.92. What is the ratio of the Value added (% of GDP) in Slovenia in 2012 to that in 2013?
Provide a succinct answer. 0.96. What is the difference between the highest and the second highest Value added (% of GDP) in Bolivia?
Provide a short and direct response. 0.28. What is the difference between the highest and the second highest Value added (% of GDP) of Denmark?
Your response must be concise. 0.63. What is the difference between the highest and the second highest Value added (% of GDP) of Niger?
Provide a short and direct response. 0.55. What is the difference between the highest and the second highest Value added (% of GDP) in Slovenia?
Your response must be concise. 0.86. What is the difference between the highest and the lowest Value added (% of GDP) of Bolivia?
Make the answer very short. 1.45. What is the difference between the highest and the lowest Value added (% of GDP) of Denmark?
Your answer should be very brief. 1.77. What is the difference between the highest and the lowest Value added (% of GDP) in Niger?
Your answer should be compact. 1.84. What is the difference between the highest and the lowest Value added (% of GDP) in Slovenia?
Your response must be concise. 3.75. 